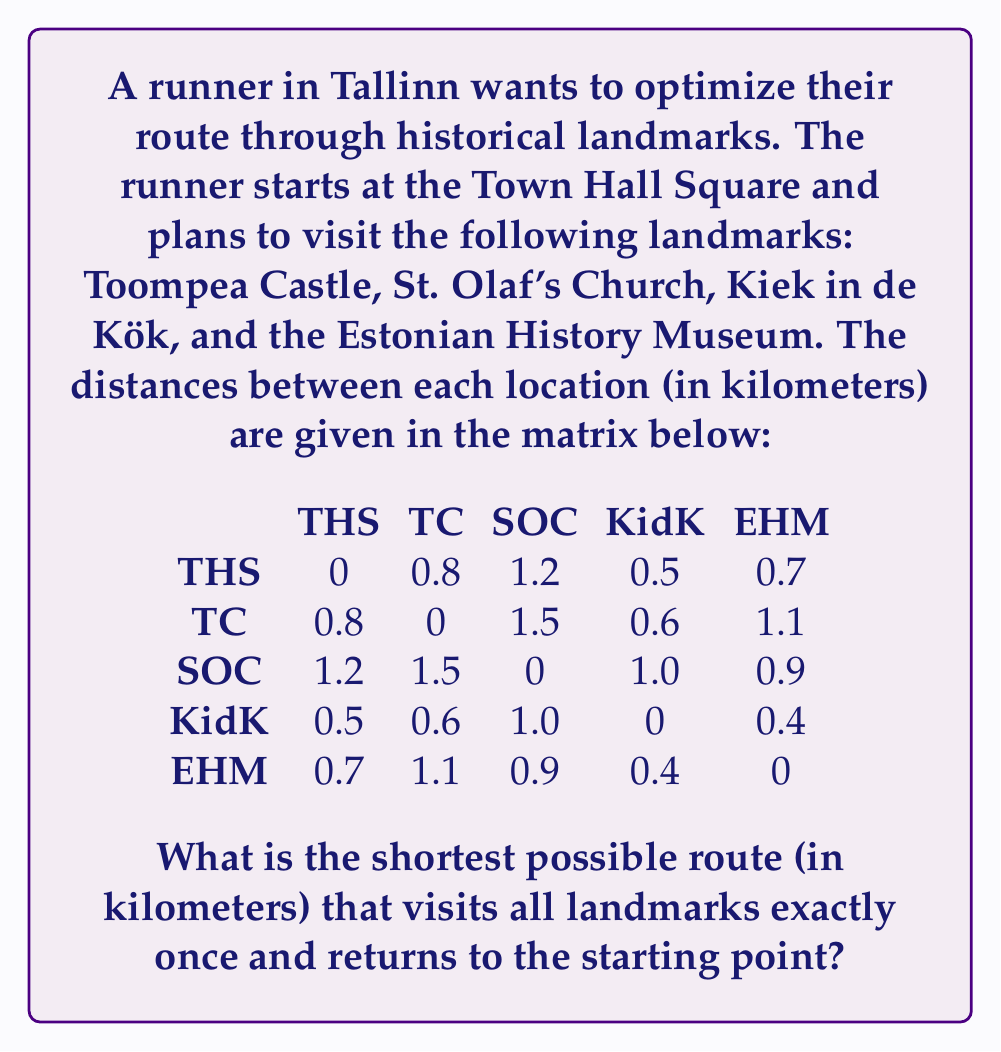Help me with this question. This problem is a classic example of the Traveling Salesman Problem (TSP) in Operations Research. To solve it, we'll use the following steps:

1) First, we need to list all possible routes. Since we start and end at the Town Hall Square (THS), we have $(n-1)! = 4! = 24$ possible routes, where $n$ is the number of locations.

2) Calculate the total distance for each route:

   For example, let's calculate the distance for the route THS → TC → SOC → KidK → EHM → THS:
   $0.8 + 1.5 + 1.0 + 0.4 + 0.7 = 4.4$ km

3) We need to do this for all 24 possible routes. Here are a few more examples:

   THS → TC → SOC → EHM → KidK → THS: $0.8 + 1.5 + 0.9 + 0.4 + 0.5 = 4.1$ km
   THS → SOC → TC → KidK → EHM → THS: $1.2 + 1.5 + 0.6 + 0.4 + 0.7 = 4.4$ km
   THS → SOC → EHM → KidK → TC → THS: $1.2 + 0.9 + 0.4 + 0.6 + 0.8 = 3.9$ km

4) After calculating all routes, we find that the shortest route is:

   THS → KidK → EHM → SOC → TC → THS

5) The total distance of this route is:
   $0.5 + 0.4 + 0.9 + 1.5 + 0.8 = 4.1$ km

This route minimizes the total distance while visiting all landmarks exactly once and returning to the starting point.
Answer: The shortest possible route is 4.1 km. 